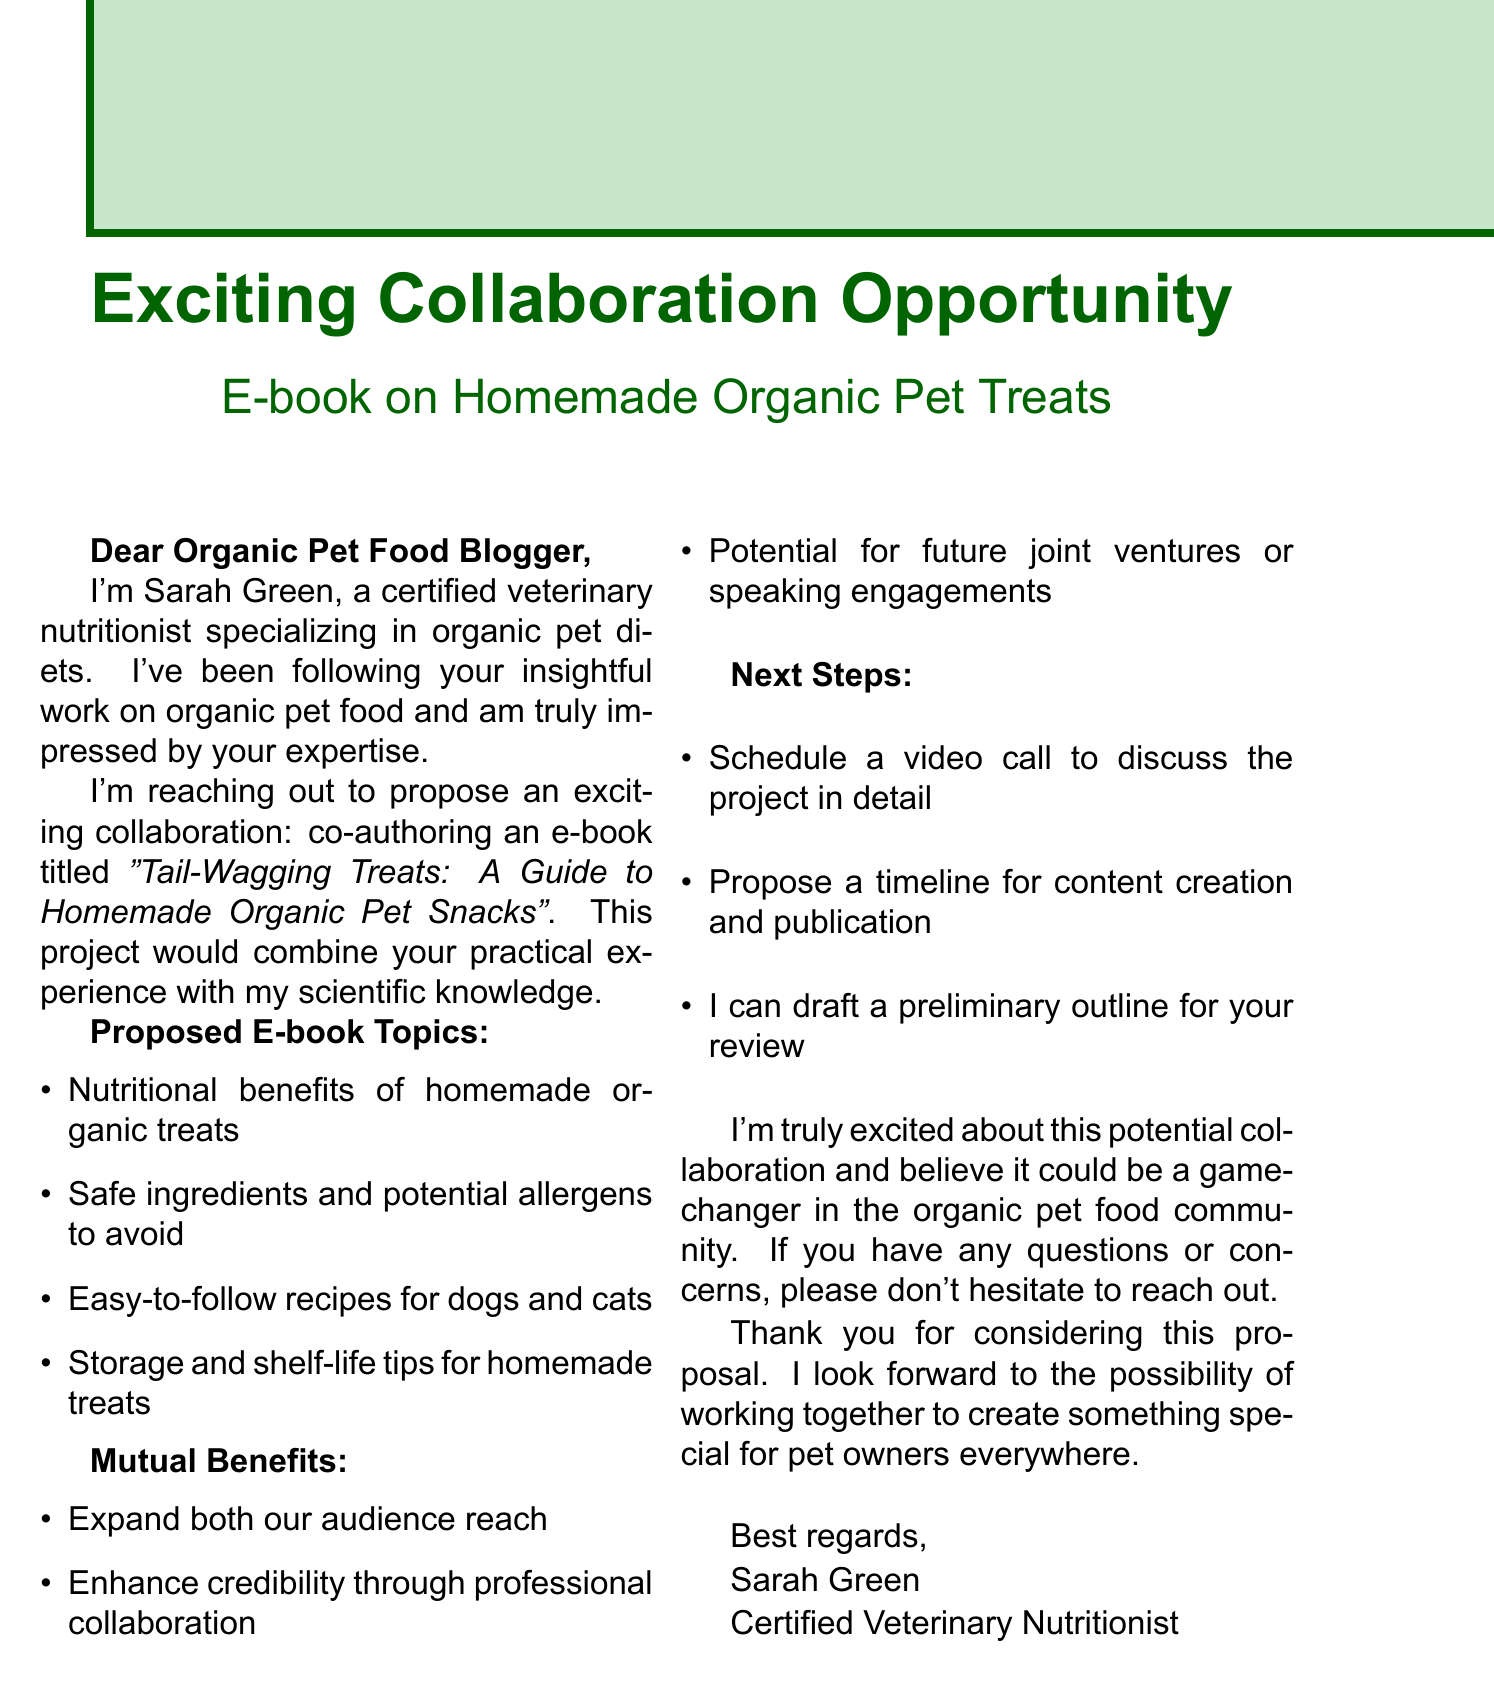What is the name of the veterinary nutritionist? The document presents Sarah Green as the veterinary nutritionist reaching out for collaboration.
Answer: Sarah Green What is the title of the proposed e-book? The e-book proposal includes a specific title that indicates its purpose related to pet snacks.
Answer: Tail-Wagging Treats: A Guide to Homemade Organic Pet Snacks What are two proposed topics for the e-book? The document lists several topics to be covered in the e-book, asking for two provides insight into its content areas.
Answer: Nutritional benefits of homemade organic treats, Easy-to-follow recipes for dogs and cats What does the collaboration aim to enhance? The text mentions a specific outcome that would improve both parties' standing within the pet food community.
Answer: Credibility How many mutual benefits are mentioned? The section on mutual benefits outlines several advantages, determining how many helps grasp the scope of the collaboration.
Answer: Three What does Sarah suggest for the next step? The next steps section lists actions to facilitate the collaboration, highlighting the initial step suggested.
Answer: Schedule a video call What is the document's primary purpose? Understanding the main intention of the email can provide context for the information shared within.
Answer: Collaboration proposal Who is invited to reach out with questions? Recognizing the communication style and openness promotes further engagement with the proposal.
Answer: The blogger 